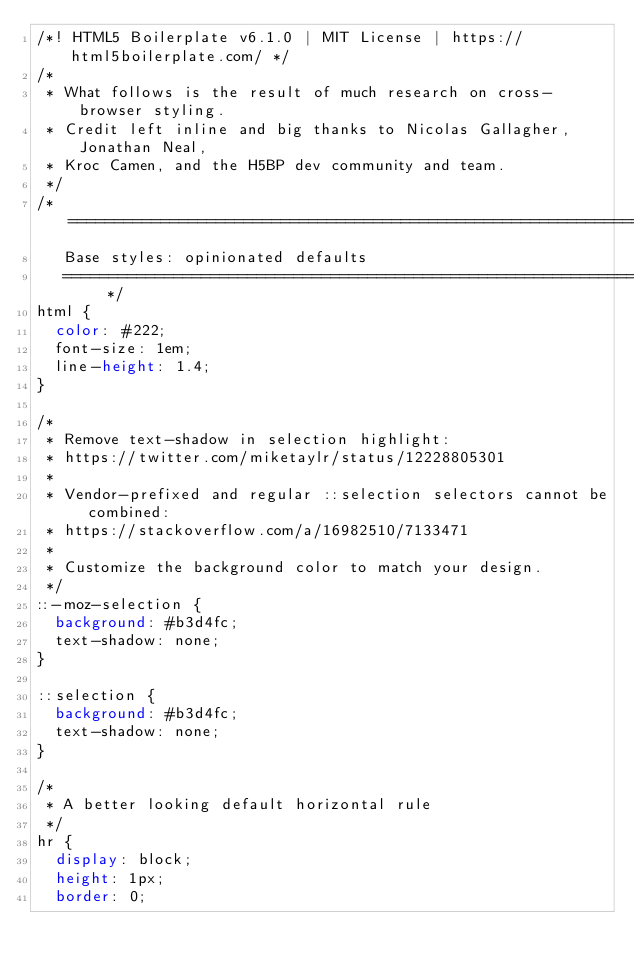<code> <loc_0><loc_0><loc_500><loc_500><_CSS_>/*! HTML5 Boilerplate v6.1.0 | MIT License | https://html5boilerplate.com/ */
/*
 * What follows is the result of much research on cross-browser styling.
 * Credit left inline and big thanks to Nicolas Gallagher, Jonathan Neal,
 * Kroc Camen, and the H5BP dev community and team.
 */
/* ==========================================================================
   Base styles: opinionated defaults
   ========================================================================== */
html {
  color: #222;
  font-size: 1em;
  line-height: 1.4;
}

/*
 * Remove text-shadow in selection highlight:
 * https://twitter.com/miketaylr/status/12228805301
 *
 * Vendor-prefixed and regular ::selection selectors cannot be combined:
 * https://stackoverflow.com/a/16982510/7133471
 *
 * Customize the background color to match your design.
 */
::-moz-selection {
  background: #b3d4fc;
  text-shadow: none;
}

::selection {
  background: #b3d4fc;
  text-shadow: none;
}

/*
 * A better looking default horizontal rule
 */
hr {
  display: block;
  height: 1px;
  border: 0;</code> 